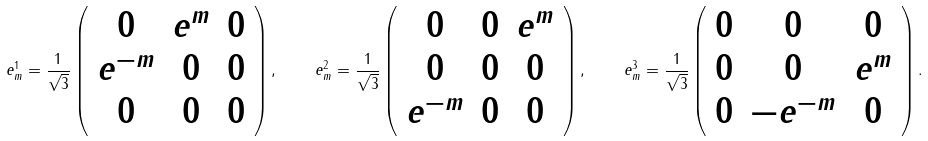Convert formula to latex. <formula><loc_0><loc_0><loc_500><loc_500>e ^ { 1 } _ { m } = \frac { 1 } { \sqrt { 3 } } \left ( \begin{array} { c c c } 0 & e ^ { m } & 0 \\ e ^ { - m } & 0 & 0 \\ 0 & 0 & 0 \\ \end{array} \right ) , \quad e ^ { 2 } _ { m } = \frac { 1 } { \sqrt { 3 } } \left ( \begin{array} { c c c } 0 & 0 & e ^ { m } \\ 0 & 0 & 0 \\ e ^ { - m } & 0 & 0 \\ \end{array} \right ) , \quad e ^ { 3 } _ { m } = \frac { 1 } { \sqrt { 3 } } \left ( \begin{array} { c c c } 0 & 0 & 0 \\ 0 & 0 & e ^ { m } \\ 0 & - e ^ { - m } & 0 \\ \end{array} \right ) .</formula> 